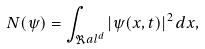<formula> <loc_0><loc_0><loc_500><loc_500>N ( \psi ) = \int _ { \Re a l ^ { d } } | \psi ( x , t ) | ^ { 2 } \, d x ,</formula> 